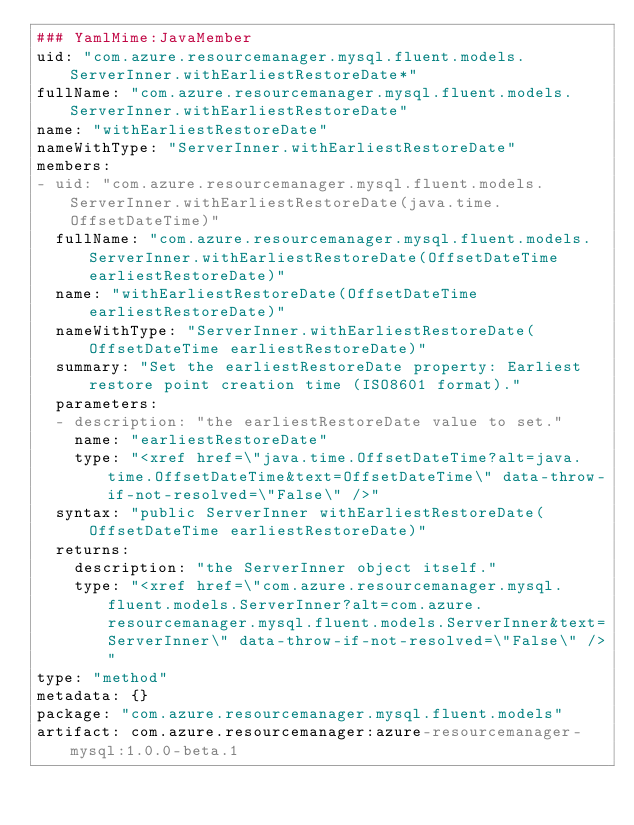<code> <loc_0><loc_0><loc_500><loc_500><_YAML_>### YamlMime:JavaMember
uid: "com.azure.resourcemanager.mysql.fluent.models.ServerInner.withEarliestRestoreDate*"
fullName: "com.azure.resourcemanager.mysql.fluent.models.ServerInner.withEarliestRestoreDate"
name: "withEarliestRestoreDate"
nameWithType: "ServerInner.withEarliestRestoreDate"
members:
- uid: "com.azure.resourcemanager.mysql.fluent.models.ServerInner.withEarliestRestoreDate(java.time.OffsetDateTime)"
  fullName: "com.azure.resourcemanager.mysql.fluent.models.ServerInner.withEarliestRestoreDate(OffsetDateTime earliestRestoreDate)"
  name: "withEarliestRestoreDate(OffsetDateTime earliestRestoreDate)"
  nameWithType: "ServerInner.withEarliestRestoreDate(OffsetDateTime earliestRestoreDate)"
  summary: "Set the earliestRestoreDate property: Earliest restore point creation time (ISO8601 format)."
  parameters:
  - description: "the earliestRestoreDate value to set."
    name: "earliestRestoreDate"
    type: "<xref href=\"java.time.OffsetDateTime?alt=java.time.OffsetDateTime&text=OffsetDateTime\" data-throw-if-not-resolved=\"False\" />"
  syntax: "public ServerInner withEarliestRestoreDate(OffsetDateTime earliestRestoreDate)"
  returns:
    description: "the ServerInner object itself."
    type: "<xref href=\"com.azure.resourcemanager.mysql.fluent.models.ServerInner?alt=com.azure.resourcemanager.mysql.fluent.models.ServerInner&text=ServerInner\" data-throw-if-not-resolved=\"False\" />"
type: "method"
metadata: {}
package: "com.azure.resourcemanager.mysql.fluent.models"
artifact: com.azure.resourcemanager:azure-resourcemanager-mysql:1.0.0-beta.1
</code> 